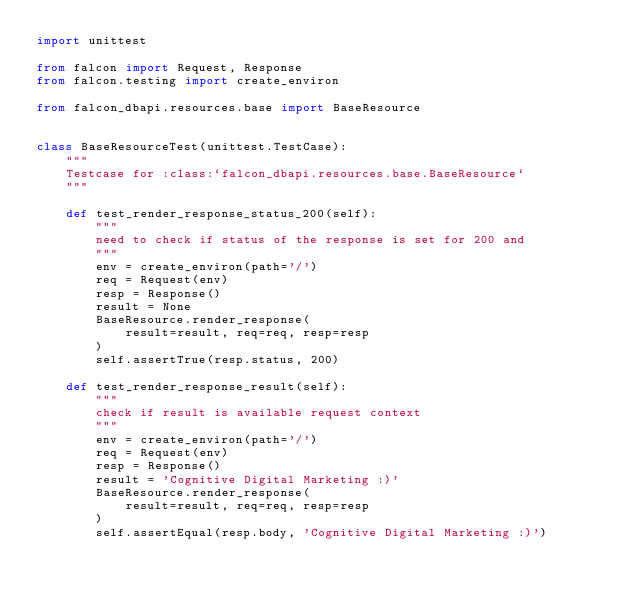Convert code to text. <code><loc_0><loc_0><loc_500><loc_500><_Python_>import unittest

from falcon import Request, Response
from falcon.testing import create_environ

from falcon_dbapi.resources.base import BaseResource


class BaseResourceTest(unittest.TestCase):
    """
    Testcase for :class:`falcon_dbapi.resources.base.BaseResource`
    """

    def test_render_response_status_200(self):
        """
        need to check if status of the response is set for 200 and
        """
        env = create_environ(path='/')
        req = Request(env)
        resp = Response()
        result = None
        BaseResource.render_response(
            result=result, req=req, resp=resp
        )
        self.assertTrue(resp.status, 200)

    def test_render_response_result(self):
        """
        check if result is available request context
        """
        env = create_environ(path='/')
        req = Request(env)
        resp = Response()
        result = 'Cognitive Digital Marketing :)'
        BaseResource.render_response(
            result=result, req=req, resp=resp
        )
        self.assertEqual(resp.body, 'Cognitive Digital Marketing :)')
</code> 